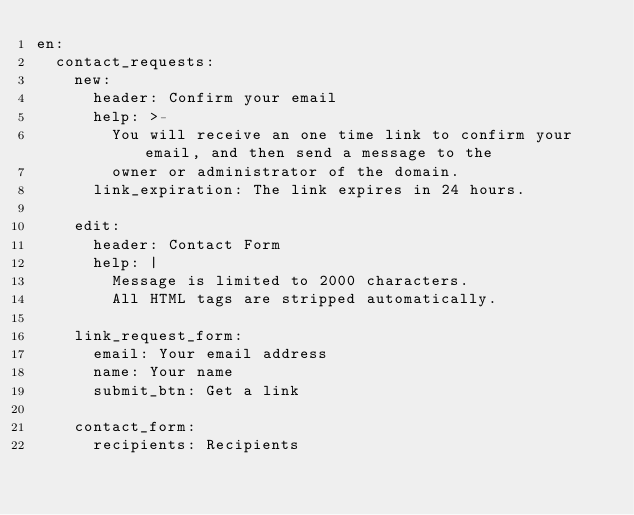Convert code to text. <code><loc_0><loc_0><loc_500><loc_500><_YAML_>en:
  contact_requests:
    new:
      header: Confirm your email
      help: >-
        You will receive an one time link to confirm your email, and then send a message to the
        owner or administrator of the domain.
      link_expiration: The link expires in 24 hours.

    edit:
      header: Contact Form
      help: |
        Message is limited to 2000 characters.
        All HTML tags are stripped automatically.

    link_request_form:
      email: Your email address
      name: Your name
      submit_btn: Get a link

    contact_form:
      recipients: Recipients</code> 